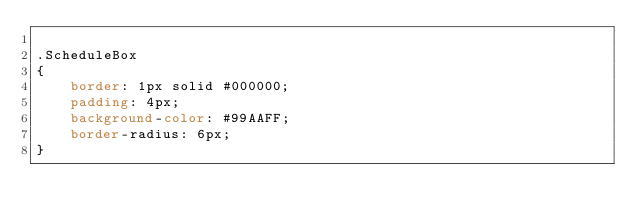Convert code to text. <code><loc_0><loc_0><loc_500><loc_500><_CSS_>
.ScheduleBox
{
    border: 1px solid #000000;
    padding: 4px;
    background-color: #99AAFF;
    border-radius: 6px;
}</code> 